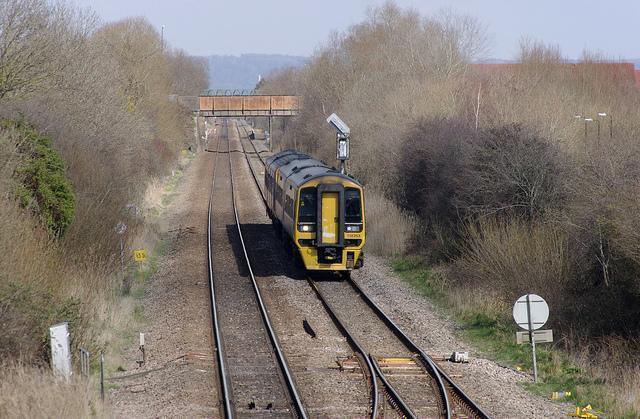How many tracks can you spot?
Give a very brief answer. 2. 